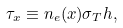Convert formula to latex. <formula><loc_0><loc_0><loc_500><loc_500>\tau _ { x } \equiv n _ { e } ( x ) \sigma _ { T } h ,</formula> 